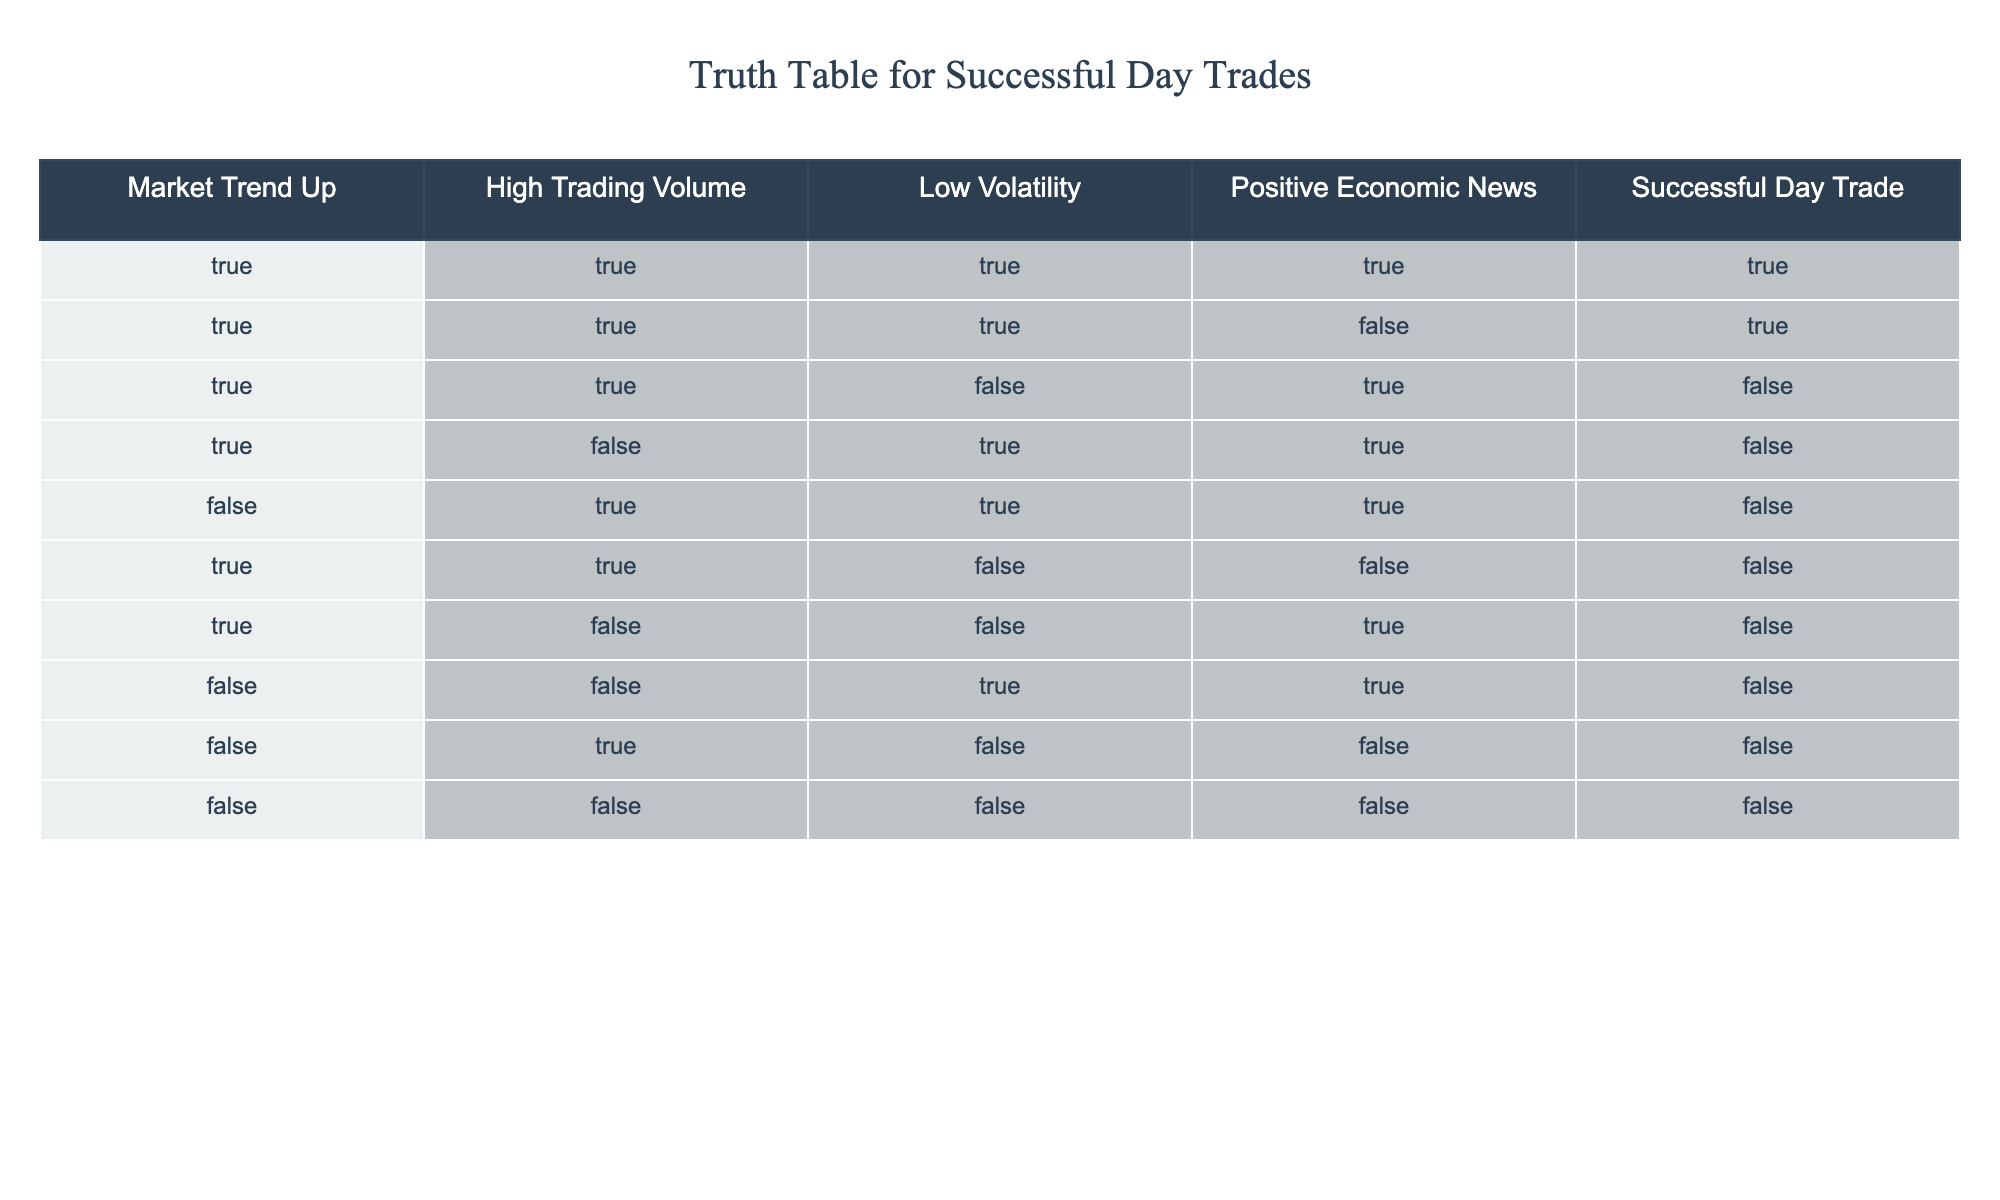What is the total number of successful day trades when the market trend is up? There are 5 rows where the market trend is true. Out of those, 3 rows have successful day trades (the last column is true). Thus, the total successful day trades is 3.
Answer: 3 How many instances of low volatility are there in the data? I will count the rows where low volatility is true, which occurs in 5 rows of the table (the third column). Therefore, there are 5 instances of low volatility.
Answer: 5 Is successful day trading possible when there is low volatility and positive economic news? Looking at the rows where both low volatility and positive economic news are true, there are only 2 such instances, but only one is successful. Thus, the answer is no.
Answer: No What is the condition that leads to a successful day trade when the market trend is false? There are no rows with a successful day trade when the market trend is false (all corresponding entries in the last column are false). Hence, no specific condition will lead to successful trades under this scenario.
Answer: None If the market trend is up and positive economic news is present, what is the total number of successful trades? First, identify the rows where the market trend is up and positive economic news is true, which yields 3 rows. Out of those, 2 are successful trades. Thus, the total number is 2.
Answer: 2 What percentage of day trades are successful when the market trend is up? Out of the 5 instances where the market trend is up, there are 3 successful trades. To find the percentage, I calculate (3 successful trades / 5 total trades) * 100, which equals 60%.
Answer: 60% Can you confirm whether high trading volume guarantees a successful day trade? In reviewing the rows with high trading volume, there are 4 instances. Out of these, 2 are unsuccessful. Therefore, high trading volume does not guarantee success.
Answer: No How many successful trades occur with both high trading volume and low volatility? There are 3 rows with both high trading volume and low volatility. Out of those, only 1 is successful. Hence, there is 1 successful trade under these conditions.
Answer: 1 What is the relationship between positive economic news and successful day trades when the market trend is down? In instances where the market trend is false, there are 3 trades with positive economic news, and all 3 of those trades are unsuccessful. Thus, it indicates a negative correlation.
Answer: Negative correlation 